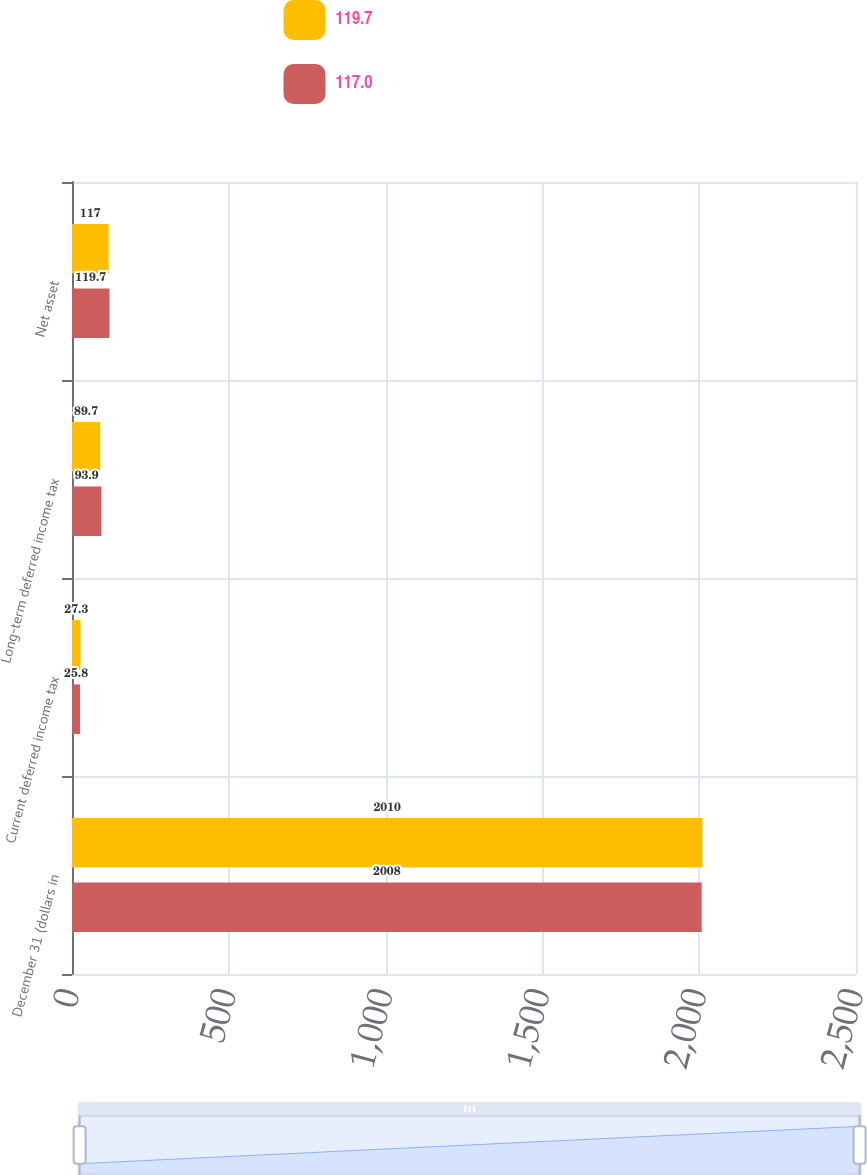Convert chart to OTSL. <chart><loc_0><loc_0><loc_500><loc_500><stacked_bar_chart><ecel><fcel>December 31 (dollars in<fcel>Current deferred income tax<fcel>Long-term deferred income tax<fcel>Net asset<nl><fcel>119.7<fcel>2010<fcel>27.3<fcel>89.7<fcel>117<nl><fcel>117<fcel>2008<fcel>25.8<fcel>93.9<fcel>119.7<nl></chart> 